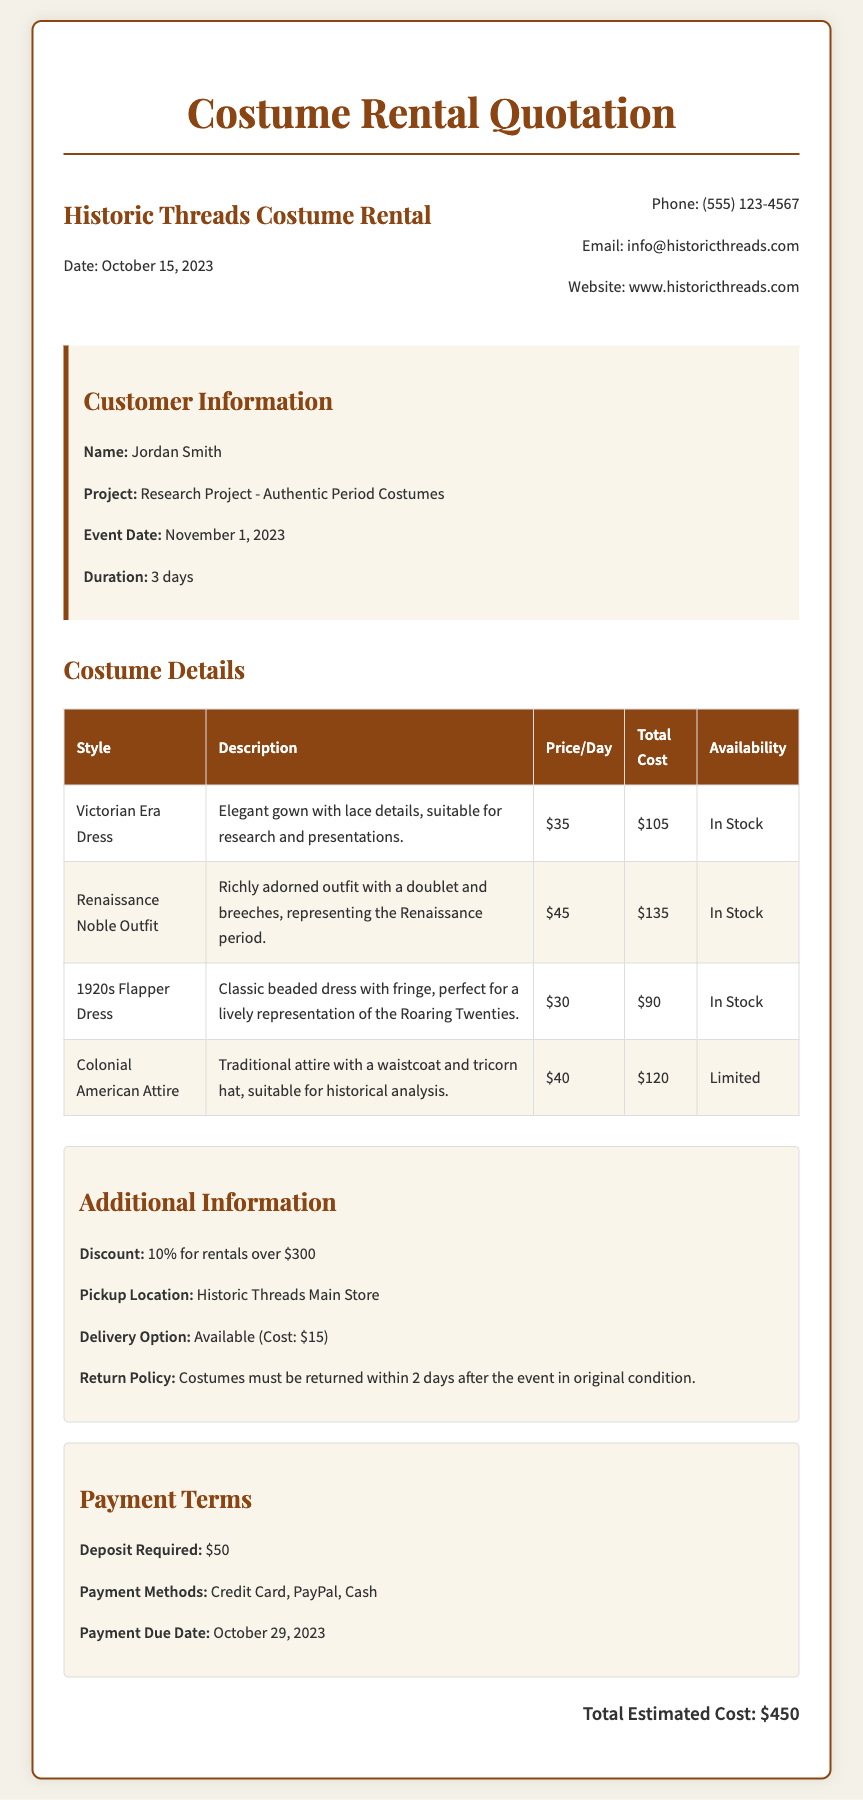What is the date of the quotation? The date listed in the document for the quotation is October 15, 2023.
Answer: October 15, 2023 Who is the customer? The customer name provided in the document is Jordan Smith.
Answer: Jordan Smith What is the total estimated cost? The total estimated cost is indicated as $450 in the document.
Answer: $450 How long is the rental duration? The rental duration mentioned for the costumes is 3 days.
Answer: 3 days What is the price of the Victorian Era Dress per day? The document states that the Victorian Era Dress costs $35 per day.
Answer: $35 What discount is offered for rentals over $300? The document mentions a 10% discount for rentals exceeding $300.
Answer: 10% When is the payment due date? The payment due date specified in the document is October 29, 2023.
Answer: October 29, 2023 What is the cost of the delivery option? The cost for the delivery option, as stated in the document, is $15.
Answer: $15 What is the return policy for the costumes? The document specifies that costumes must be returned within 2 days after the event.
Answer: 2 days 